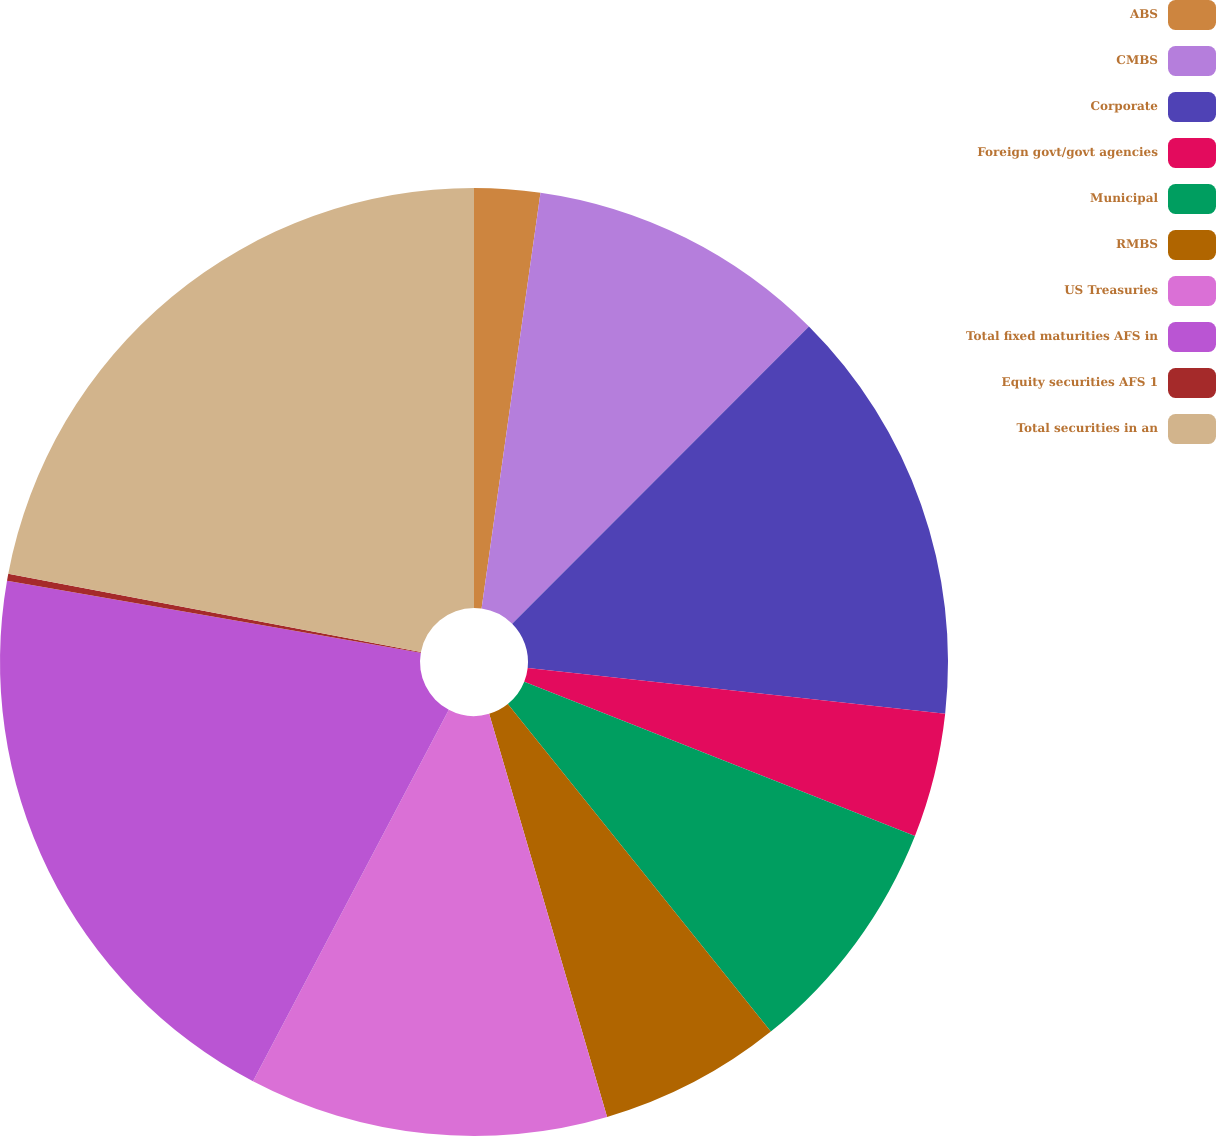Convert chart to OTSL. <chart><loc_0><loc_0><loc_500><loc_500><pie_chart><fcel>ABS<fcel>CMBS<fcel>Corporate<fcel>Foreign govt/govt agencies<fcel>Municipal<fcel>RMBS<fcel>US Treasuries<fcel>Total fixed maturities AFS in<fcel>Equity securities AFS 1<fcel>Total securities in an<nl><fcel>2.24%<fcel>10.25%<fcel>14.25%<fcel>4.24%<fcel>8.25%<fcel>6.24%<fcel>12.25%<fcel>20.02%<fcel>0.24%<fcel>22.02%<nl></chart> 